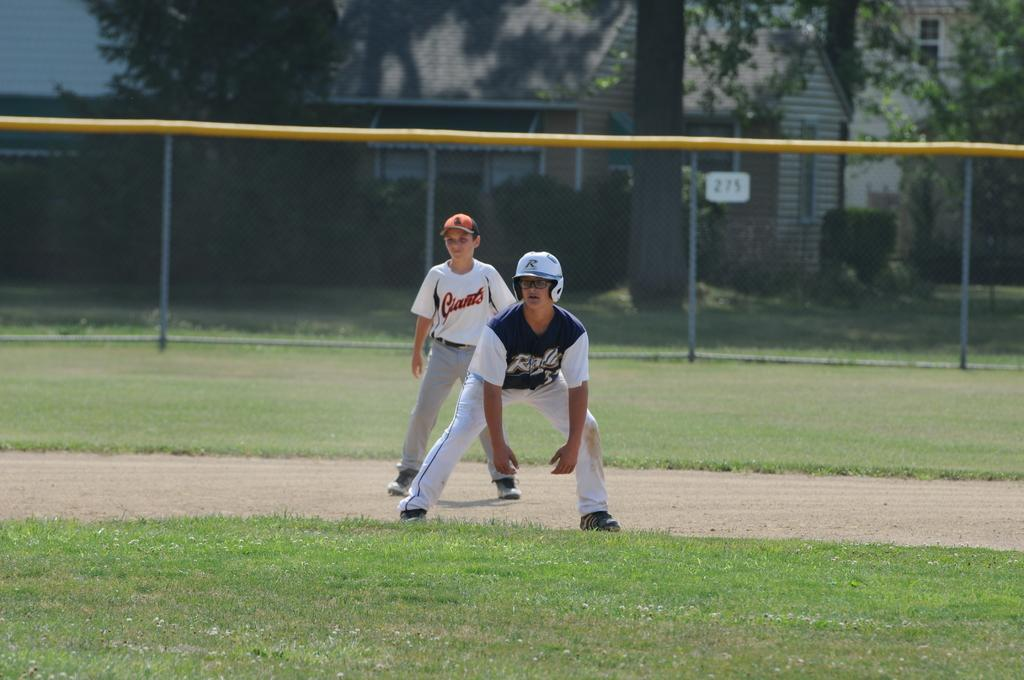<image>
Offer a succinct explanation of the picture presented. Two ball players on a field with one of them playing for the Giants. 